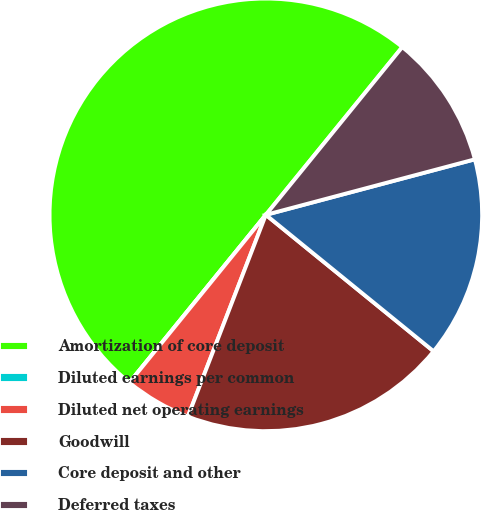<chart> <loc_0><loc_0><loc_500><loc_500><pie_chart><fcel>Amortization of core deposit<fcel>Diluted earnings per common<fcel>Diluted net operating earnings<fcel>Goodwill<fcel>Core deposit and other<fcel>Deferred taxes<nl><fcel>50.0%<fcel>0.0%<fcel>5.0%<fcel>20.0%<fcel>15.0%<fcel>10.0%<nl></chart> 